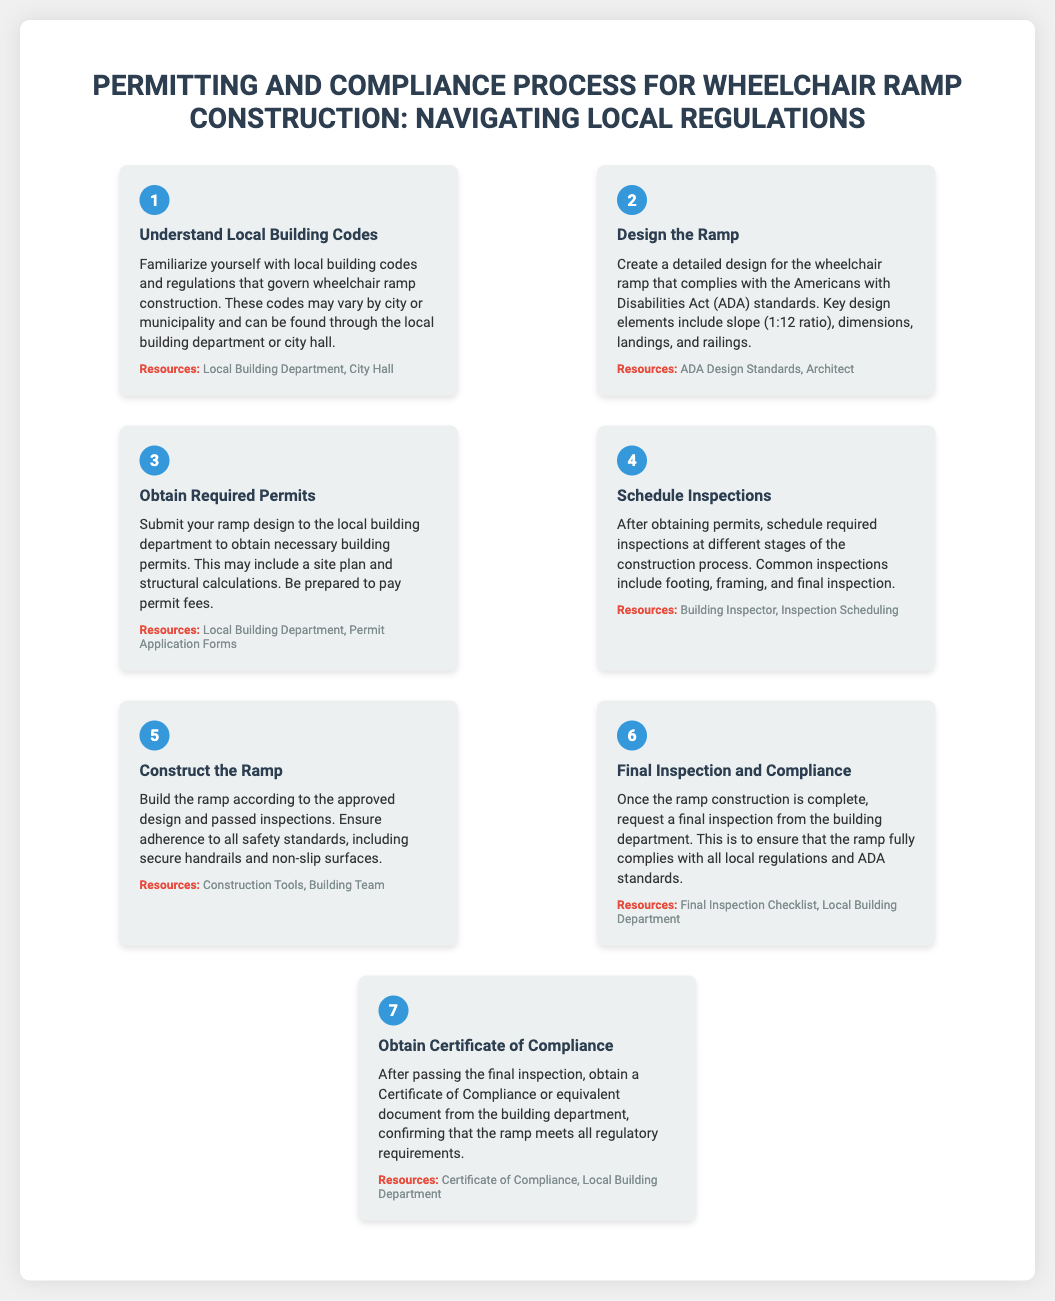What is the first step in the process? The first step in the process is to understand local building codes and regulations.
Answer: Understand Local Building Codes What is the required slope for ramp design? The required slope for ramp design according to ADA standards is a 1:12 ratio.
Answer: 1:12 ratio Which department issues the Certificate of Compliance? The Certificate of Compliance is obtained from the local building department.
Answer: Local Building Department What should be included in the ramp design submission? The ramp design submission should include a site plan and structural calculations.
Answer: Site plan and structural calculations How many steps are in the process infographic? There are a total of seven steps in the process infographic.
Answer: Seven steps What type of inspection must be scheduled after obtaining permits? The common inspections include footing, framing, and final inspection.
Answer: Footing, framing, and final inspection Which resource is mentioned for ADA design standards? An architect is mentioned as a resource for ADA design standards.
Answer: Architect 